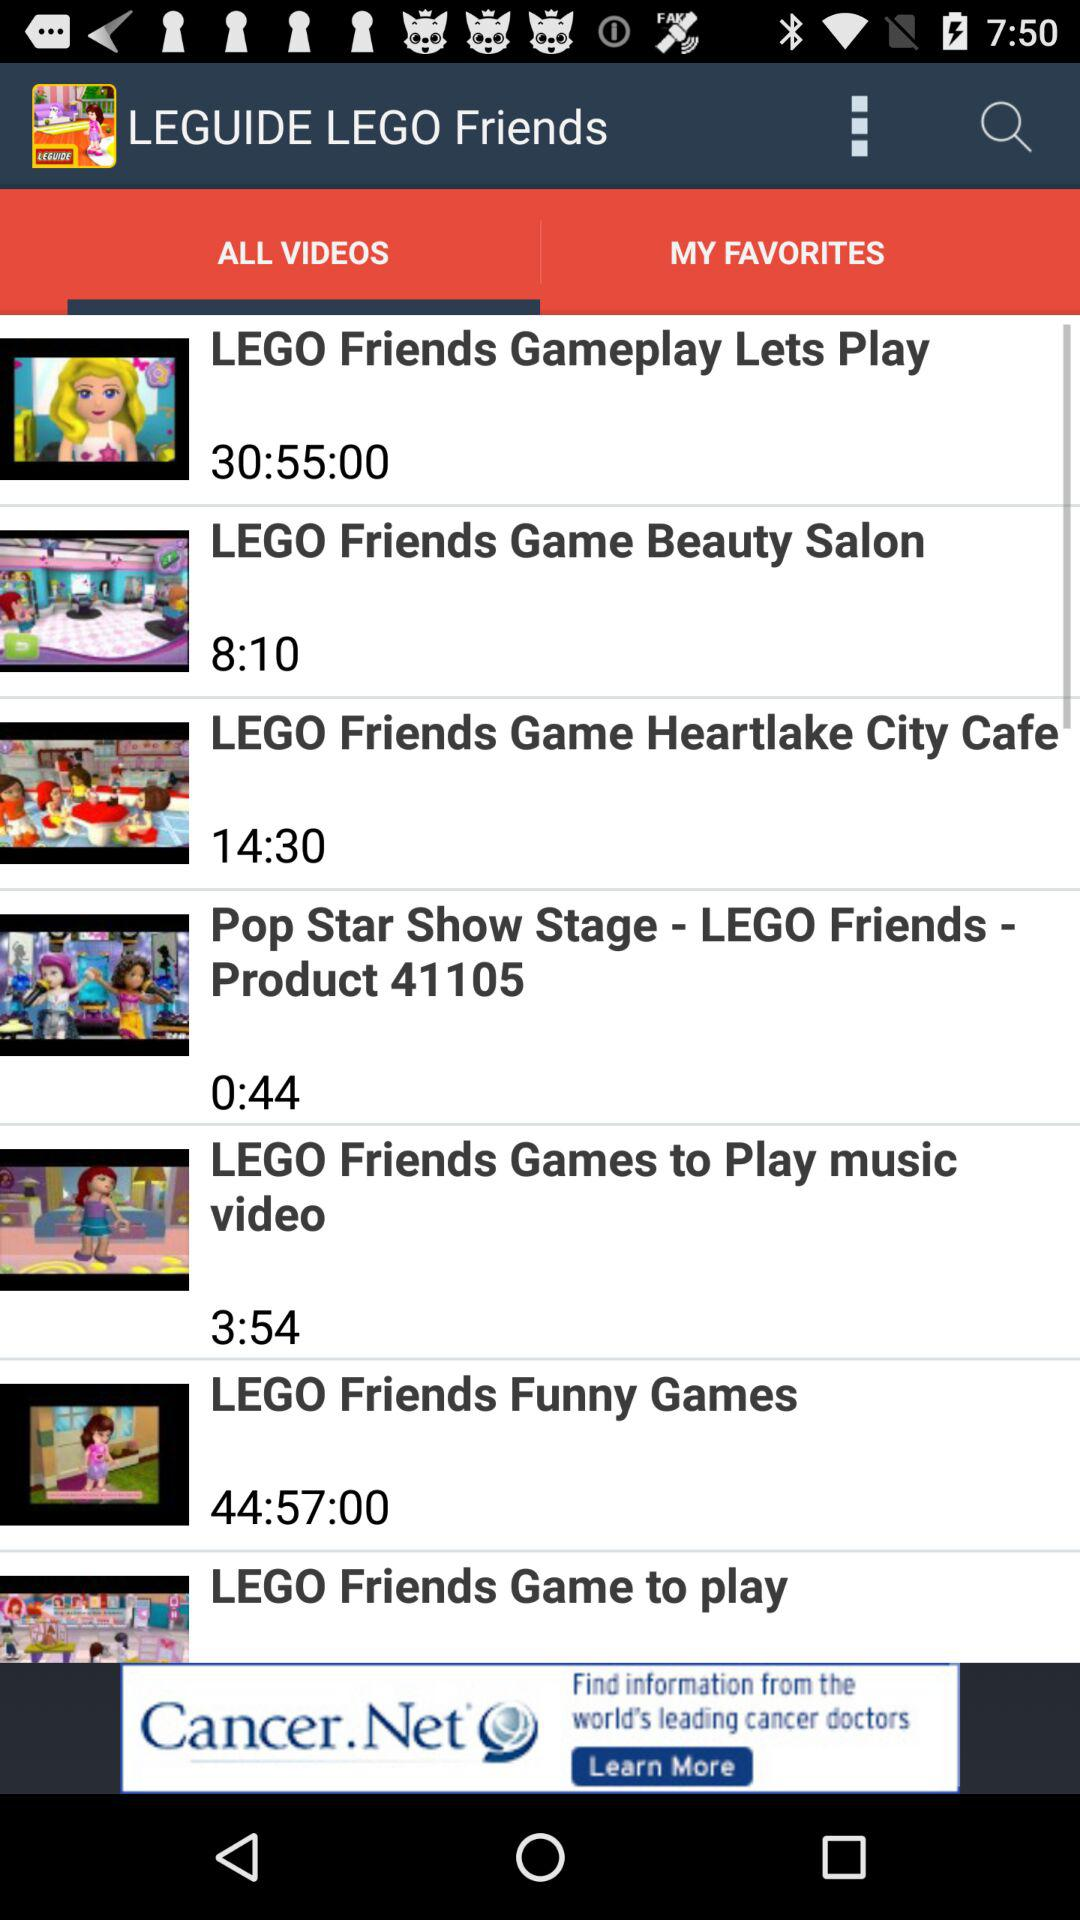How many videos are shorter than 10 minutes?
Answer the question using a single word or phrase. 3 